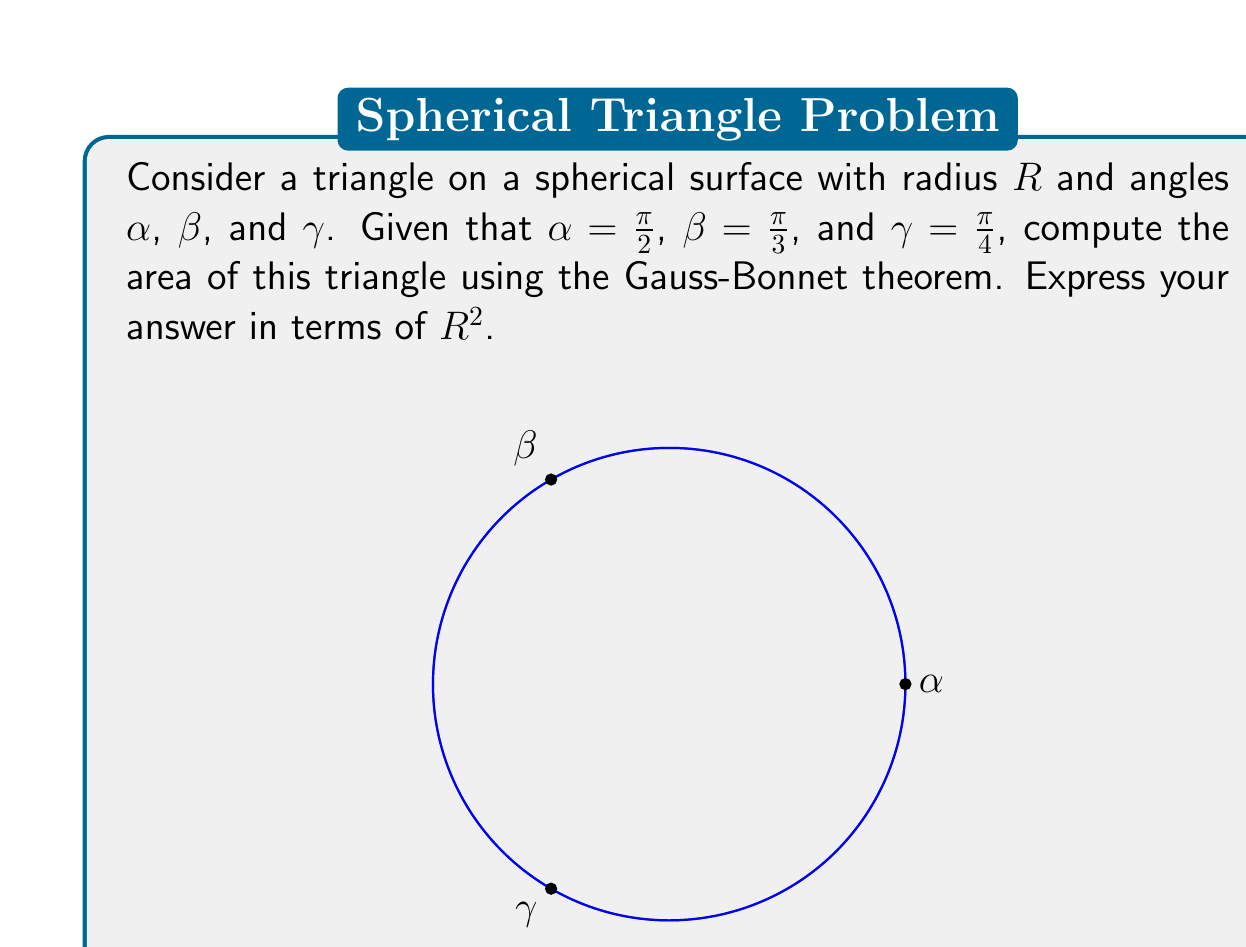Give your solution to this math problem. Let's approach this step-by-step using the Gauss-Bonnet theorem:

1) The Gauss-Bonnet theorem for a triangle on a sphere states:

   $$A + R^2(\alpha + \beta + \gamma - \pi) = 2\pi R^2$$

   where $A$ is the area of the triangle, $R$ is the radius of the sphere, and $\alpha$, $\beta$, $\gamma$ are the angles of the triangle.

2) We are given:
   $\alpha = \frac{\pi}{2}$
   $\beta = \frac{\pi}{3}$
   $\gamma = \frac{\pi}{4}$

3) Let's substitute these values into the equation:

   $$A + R^2(\frac{\pi}{2} + \frac{\pi}{3} + \frac{\pi}{4} - \pi) = 2\pi R^2$$

4) Simplify the expression inside the parentheses:

   $$A + R^2(\frac{6\pi}{12} + \frac{4\pi}{12} + \frac{3\pi}{12} - \frac{12\pi}{12}) = 2\pi R^2$$
   $$A + R^2(\frac{13\pi}{12} - \pi) = 2\pi R^2$$
   $$A + R^2(\frac{\pi}{12}) = 2\pi R^2$$

5) Now, let's solve for $A$:

   $$A = 2\pi R^2 - \frac{\pi}{12}R^2$$
   $$A = (\frac{24\pi}{12} - \frac{\pi}{12})R^2$$
   $$A = \frac{23\pi}{12}R^2$$

Thus, we have derived the area of the triangle on the spherical surface.
Answer: $\frac{23\pi}{12}R^2$ 